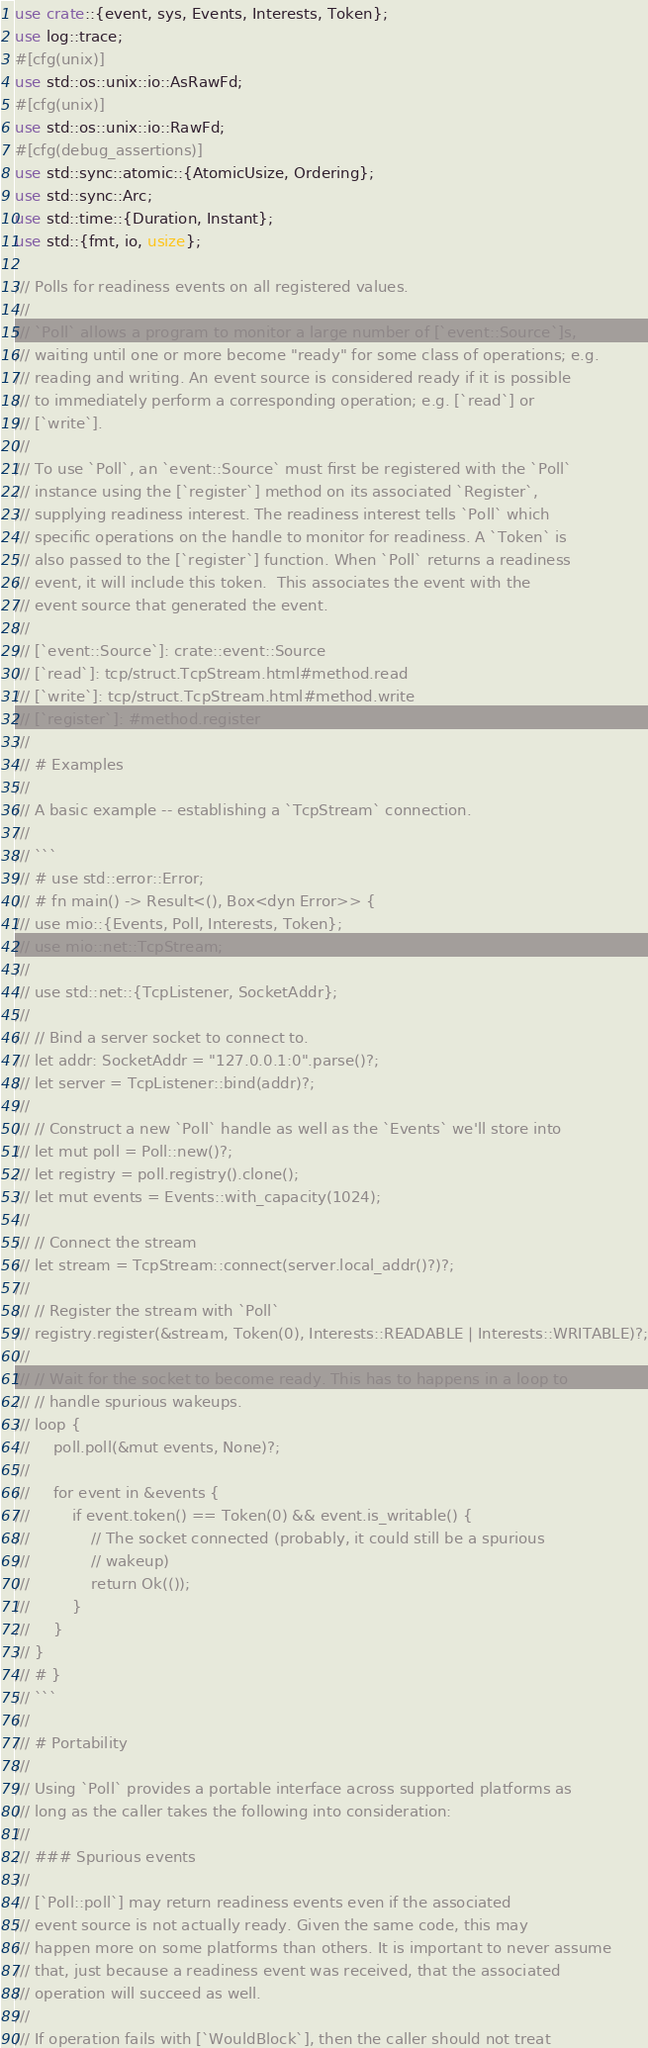<code> <loc_0><loc_0><loc_500><loc_500><_Rust_>use crate::{event, sys, Events, Interests, Token};
use log::trace;
#[cfg(unix)]
use std::os::unix::io::AsRawFd;
#[cfg(unix)]
use std::os::unix::io::RawFd;
#[cfg(debug_assertions)]
use std::sync::atomic::{AtomicUsize, Ordering};
use std::sync::Arc;
use std::time::{Duration, Instant};
use std::{fmt, io, usize};

/// Polls for readiness events on all registered values.
///
/// `Poll` allows a program to monitor a large number of [`event::Source`]s,
/// waiting until one or more become "ready" for some class of operations; e.g.
/// reading and writing. An event source is considered ready if it is possible
/// to immediately perform a corresponding operation; e.g. [`read`] or
/// [`write`].
///
/// To use `Poll`, an `event::Source` must first be registered with the `Poll`
/// instance using the [`register`] method on its associated `Register`,
/// supplying readiness interest. The readiness interest tells `Poll` which
/// specific operations on the handle to monitor for readiness. A `Token` is
/// also passed to the [`register`] function. When `Poll` returns a readiness
/// event, it will include this token.  This associates the event with the
/// event source that generated the event.
///
/// [`event::Source`]: crate::event::Source
/// [`read`]: tcp/struct.TcpStream.html#method.read
/// [`write`]: tcp/struct.TcpStream.html#method.write
/// [`register`]: #method.register
///
/// # Examples
///
/// A basic example -- establishing a `TcpStream` connection.
///
/// ```
/// # use std::error::Error;
/// # fn main() -> Result<(), Box<dyn Error>> {
/// use mio::{Events, Poll, Interests, Token};
/// use mio::net::TcpStream;
///
/// use std::net::{TcpListener, SocketAddr};
///
/// // Bind a server socket to connect to.
/// let addr: SocketAddr = "127.0.0.1:0".parse()?;
/// let server = TcpListener::bind(addr)?;
///
/// // Construct a new `Poll` handle as well as the `Events` we'll store into
/// let mut poll = Poll::new()?;
/// let registry = poll.registry().clone();
/// let mut events = Events::with_capacity(1024);
///
/// // Connect the stream
/// let stream = TcpStream::connect(server.local_addr()?)?;
///
/// // Register the stream with `Poll`
/// registry.register(&stream, Token(0), Interests::READABLE | Interests::WRITABLE)?;
///
/// // Wait for the socket to become ready. This has to happens in a loop to
/// // handle spurious wakeups.
/// loop {
///     poll.poll(&mut events, None)?;
///
///     for event in &events {
///         if event.token() == Token(0) && event.is_writable() {
///             // The socket connected (probably, it could still be a spurious
///             // wakeup)
///             return Ok(());
///         }
///     }
/// }
/// # }
/// ```
///
/// # Portability
///
/// Using `Poll` provides a portable interface across supported platforms as
/// long as the caller takes the following into consideration:
///
/// ### Spurious events
///
/// [`Poll::poll`] may return readiness events even if the associated
/// event source is not actually ready. Given the same code, this may
/// happen more on some platforms than others. It is important to never assume
/// that, just because a readiness event was received, that the associated
/// operation will succeed as well.
///
/// If operation fails with [`WouldBlock`], then the caller should not treat</code> 